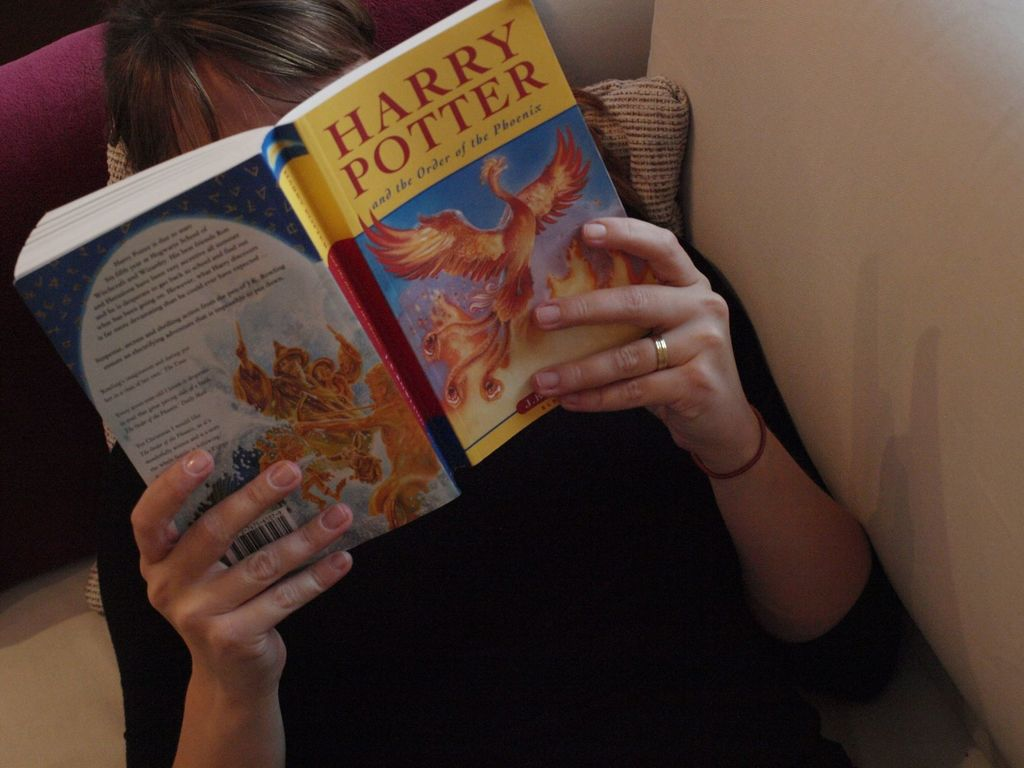What does the person's choice of book suggest about their interests? The person's choice of 'Harry Potter and the Order of the Phoenix' suggests an interest in fantasy literature, particularly stories rich in magical elements and complex narratives. This book, known for its exploration of themes like friendship, loyalty, and courage, indicates that the reader may appreciate stories that delve into emotional depth and moral challenges. The choice also hints at a love for well-developed characters and imaginative worlds. 